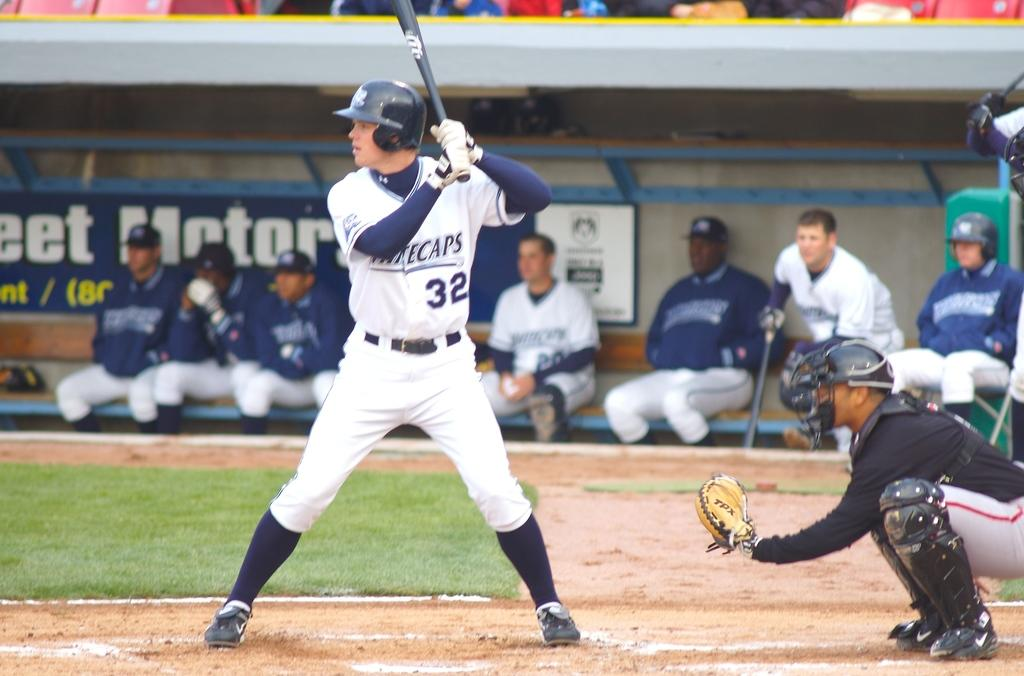<image>
Summarize the visual content of the image. Player number 32 is up to bat at this baseball game. 